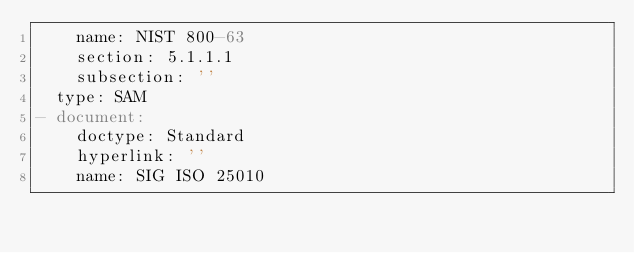Convert code to text. <code><loc_0><loc_0><loc_500><loc_500><_YAML_>    name: NIST 800-63
    section: 5.1.1.1
    subsection: ''
  type: SAM
- document:
    doctype: Standard
    hyperlink: ''
    name: SIG ISO 25010</code> 